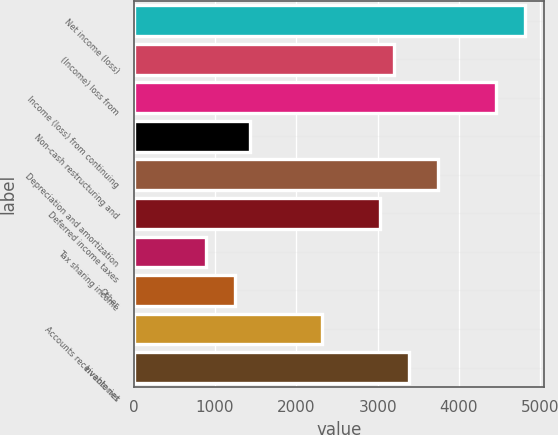Convert chart to OTSL. <chart><loc_0><loc_0><loc_500><loc_500><bar_chart><fcel>Net income (loss)<fcel>(Income) loss from<fcel>Income (loss) from continuing<fcel>Non-cash restructuring and<fcel>Depreciation and amortization<fcel>Deferred income taxes<fcel>Tax sharing income<fcel>Other<fcel>Accounts receivable net<fcel>Inventories<nl><fcel>4809.7<fcel>3206.8<fcel>4453.5<fcel>1425.8<fcel>3741.1<fcel>3028.7<fcel>891.5<fcel>1247.7<fcel>2316.3<fcel>3384.9<nl></chart> 